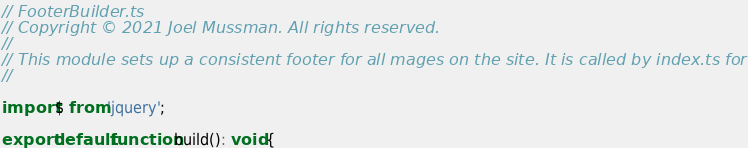<code> <loc_0><loc_0><loc_500><loc_500><_TypeScript_>// FooterBuilder.ts
// Copyright © 2021 Joel Mussman. All rights reserved.
//
// This module sets up a consistent footer for all mages on the site. It is called by index.ts for all pages.
//

import $ from 'jquery';

export default function build(): void {
</code> 